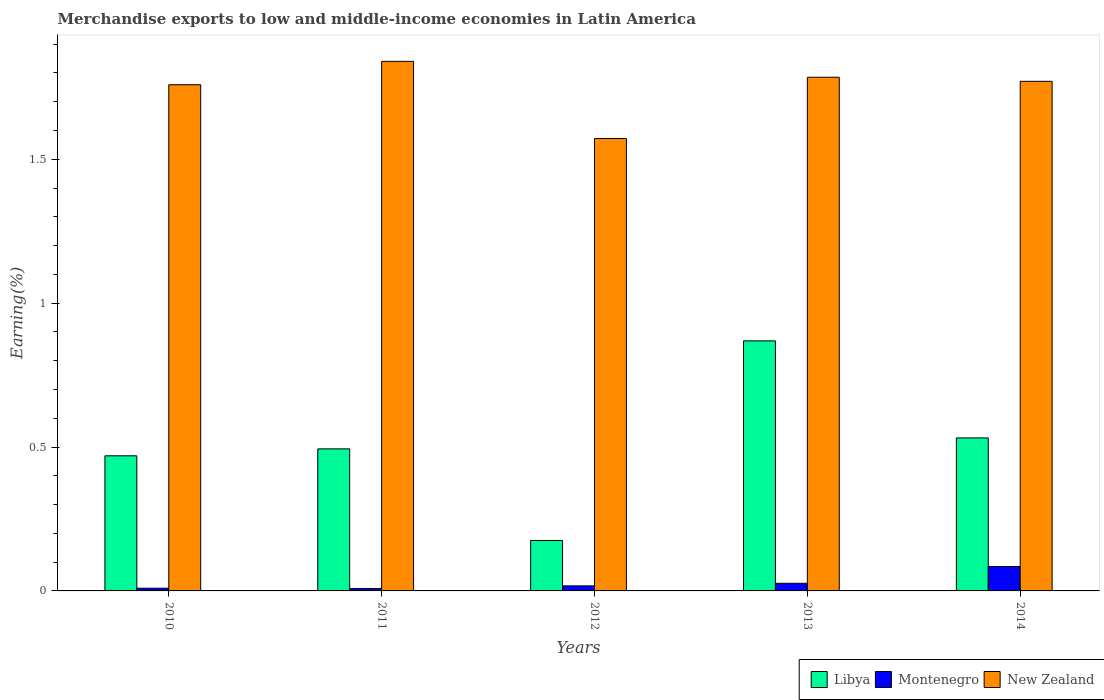How many different coloured bars are there?
Give a very brief answer. 3. How many groups of bars are there?
Keep it short and to the point. 5. Are the number of bars on each tick of the X-axis equal?
Give a very brief answer. Yes. How many bars are there on the 5th tick from the left?
Offer a very short reply. 3. In how many cases, is the number of bars for a given year not equal to the number of legend labels?
Ensure brevity in your answer.  0. What is the percentage of amount earned from merchandise exports in New Zealand in 2012?
Give a very brief answer. 1.57. Across all years, what is the maximum percentage of amount earned from merchandise exports in Montenegro?
Give a very brief answer. 0.08. Across all years, what is the minimum percentage of amount earned from merchandise exports in Libya?
Your answer should be compact. 0.18. In which year was the percentage of amount earned from merchandise exports in Libya maximum?
Offer a terse response. 2013. What is the total percentage of amount earned from merchandise exports in New Zealand in the graph?
Provide a succinct answer. 8.73. What is the difference between the percentage of amount earned from merchandise exports in Montenegro in 2011 and that in 2013?
Make the answer very short. -0.02. What is the difference between the percentage of amount earned from merchandise exports in New Zealand in 2010 and the percentage of amount earned from merchandise exports in Libya in 2012?
Provide a succinct answer. 1.58. What is the average percentage of amount earned from merchandise exports in New Zealand per year?
Your answer should be compact. 1.75. In the year 2010, what is the difference between the percentage of amount earned from merchandise exports in Montenegro and percentage of amount earned from merchandise exports in Libya?
Provide a short and direct response. -0.46. What is the ratio of the percentage of amount earned from merchandise exports in New Zealand in 2013 to that in 2014?
Provide a succinct answer. 1.01. Is the difference between the percentage of amount earned from merchandise exports in Montenegro in 2012 and 2014 greater than the difference between the percentage of amount earned from merchandise exports in Libya in 2012 and 2014?
Give a very brief answer. Yes. What is the difference between the highest and the second highest percentage of amount earned from merchandise exports in Montenegro?
Provide a succinct answer. 0.06. What is the difference between the highest and the lowest percentage of amount earned from merchandise exports in Montenegro?
Keep it short and to the point. 0.08. In how many years, is the percentage of amount earned from merchandise exports in Libya greater than the average percentage of amount earned from merchandise exports in Libya taken over all years?
Provide a succinct answer. 2. What does the 2nd bar from the left in 2010 represents?
Provide a short and direct response. Montenegro. What does the 3rd bar from the right in 2011 represents?
Give a very brief answer. Libya. Is it the case that in every year, the sum of the percentage of amount earned from merchandise exports in Montenegro and percentage of amount earned from merchandise exports in Libya is greater than the percentage of amount earned from merchandise exports in New Zealand?
Offer a terse response. No. How many bars are there?
Your response must be concise. 15. How many years are there in the graph?
Your answer should be compact. 5. Are the values on the major ticks of Y-axis written in scientific E-notation?
Provide a short and direct response. No. Does the graph contain any zero values?
Your answer should be very brief. No. Where does the legend appear in the graph?
Provide a short and direct response. Bottom right. How are the legend labels stacked?
Make the answer very short. Horizontal. What is the title of the graph?
Your answer should be very brief. Merchandise exports to low and middle-income economies in Latin America. Does "Cabo Verde" appear as one of the legend labels in the graph?
Your answer should be very brief. No. What is the label or title of the Y-axis?
Keep it short and to the point. Earning(%). What is the Earning(%) of Libya in 2010?
Ensure brevity in your answer.  0.47. What is the Earning(%) in Montenegro in 2010?
Give a very brief answer. 0.01. What is the Earning(%) of New Zealand in 2010?
Make the answer very short. 1.76. What is the Earning(%) in Libya in 2011?
Provide a succinct answer. 0.49. What is the Earning(%) of Montenegro in 2011?
Keep it short and to the point. 0.01. What is the Earning(%) in New Zealand in 2011?
Provide a short and direct response. 1.84. What is the Earning(%) of Libya in 2012?
Offer a very short reply. 0.18. What is the Earning(%) in Montenegro in 2012?
Your answer should be very brief. 0.02. What is the Earning(%) in New Zealand in 2012?
Give a very brief answer. 1.57. What is the Earning(%) of Libya in 2013?
Your answer should be compact. 0.87. What is the Earning(%) in Montenegro in 2013?
Your answer should be very brief. 0.03. What is the Earning(%) in New Zealand in 2013?
Provide a succinct answer. 1.79. What is the Earning(%) of Libya in 2014?
Provide a succinct answer. 0.53. What is the Earning(%) in Montenegro in 2014?
Keep it short and to the point. 0.08. What is the Earning(%) of New Zealand in 2014?
Your answer should be very brief. 1.77. Across all years, what is the maximum Earning(%) of Libya?
Ensure brevity in your answer.  0.87. Across all years, what is the maximum Earning(%) of Montenegro?
Provide a short and direct response. 0.08. Across all years, what is the maximum Earning(%) in New Zealand?
Your answer should be very brief. 1.84. Across all years, what is the minimum Earning(%) in Libya?
Keep it short and to the point. 0.18. Across all years, what is the minimum Earning(%) in Montenegro?
Keep it short and to the point. 0.01. Across all years, what is the minimum Earning(%) in New Zealand?
Ensure brevity in your answer.  1.57. What is the total Earning(%) in Libya in the graph?
Make the answer very short. 2.54. What is the total Earning(%) in Montenegro in the graph?
Offer a very short reply. 0.15. What is the total Earning(%) in New Zealand in the graph?
Your response must be concise. 8.73. What is the difference between the Earning(%) of Libya in 2010 and that in 2011?
Make the answer very short. -0.02. What is the difference between the Earning(%) of Montenegro in 2010 and that in 2011?
Offer a very short reply. 0. What is the difference between the Earning(%) of New Zealand in 2010 and that in 2011?
Your answer should be very brief. -0.08. What is the difference between the Earning(%) of Libya in 2010 and that in 2012?
Give a very brief answer. 0.29. What is the difference between the Earning(%) in Montenegro in 2010 and that in 2012?
Provide a succinct answer. -0.01. What is the difference between the Earning(%) of New Zealand in 2010 and that in 2012?
Give a very brief answer. 0.19. What is the difference between the Earning(%) in Libya in 2010 and that in 2013?
Provide a succinct answer. -0.4. What is the difference between the Earning(%) of Montenegro in 2010 and that in 2013?
Offer a very short reply. -0.02. What is the difference between the Earning(%) of New Zealand in 2010 and that in 2013?
Offer a very short reply. -0.03. What is the difference between the Earning(%) of Libya in 2010 and that in 2014?
Make the answer very short. -0.06. What is the difference between the Earning(%) in Montenegro in 2010 and that in 2014?
Ensure brevity in your answer.  -0.08. What is the difference between the Earning(%) in New Zealand in 2010 and that in 2014?
Your answer should be compact. -0.01. What is the difference between the Earning(%) of Libya in 2011 and that in 2012?
Give a very brief answer. 0.32. What is the difference between the Earning(%) of Montenegro in 2011 and that in 2012?
Make the answer very short. -0.01. What is the difference between the Earning(%) in New Zealand in 2011 and that in 2012?
Make the answer very short. 0.27. What is the difference between the Earning(%) in Libya in 2011 and that in 2013?
Provide a succinct answer. -0.38. What is the difference between the Earning(%) of Montenegro in 2011 and that in 2013?
Ensure brevity in your answer.  -0.02. What is the difference between the Earning(%) of New Zealand in 2011 and that in 2013?
Ensure brevity in your answer.  0.06. What is the difference between the Earning(%) in Libya in 2011 and that in 2014?
Provide a succinct answer. -0.04. What is the difference between the Earning(%) in Montenegro in 2011 and that in 2014?
Offer a terse response. -0.08. What is the difference between the Earning(%) in New Zealand in 2011 and that in 2014?
Ensure brevity in your answer.  0.07. What is the difference between the Earning(%) of Libya in 2012 and that in 2013?
Offer a very short reply. -0.69. What is the difference between the Earning(%) in Montenegro in 2012 and that in 2013?
Your answer should be very brief. -0.01. What is the difference between the Earning(%) in New Zealand in 2012 and that in 2013?
Offer a very short reply. -0.21. What is the difference between the Earning(%) in Libya in 2012 and that in 2014?
Provide a succinct answer. -0.36. What is the difference between the Earning(%) of Montenegro in 2012 and that in 2014?
Provide a succinct answer. -0.07. What is the difference between the Earning(%) of New Zealand in 2012 and that in 2014?
Offer a terse response. -0.2. What is the difference between the Earning(%) in Libya in 2013 and that in 2014?
Provide a succinct answer. 0.34. What is the difference between the Earning(%) of Montenegro in 2013 and that in 2014?
Provide a short and direct response. -0.06. What is the difference between the Earning(%) of New Zealand in 2013 and that in 2014?
Your answer should be compact. 0.01. What is the difference between the Earning(%) of Libya in 2010 and the Earning(%) of Montenegro in 2011?
Provide a short and direct response. 0.46. What is the difference between the Earning(%) of Libya in 2010 and the Earning(%) of New Zealand in 2011?
Your response must be concise. -1.37. What is the difference between the Earning(%) in Montenegro in 2010 and the Earning(%) in New Zealand in 2011?
Keep it short and to the point. -1.83. What is the difference between the Earning(%) of Libya in 2010 and the Earning(%) of Montenegro in 2012?
Ensure brevity in your answer.  0.45. What is the difference between the Earning(%) of Libya in 2010 and the Earning(%) of New Zealand in 2012?
Make the answer very short. -1.1. What is the difference between the Earning(%) of Montenegro in 2010 and the Earning(%) of New Zealand in 2012?
Keep it short and to the point. -1.56. What is the difference between the Earning(%) of Libya in 2010 and the Earning(%) of Montenegro in 2013?
Give a very brief answer. 0.44. What is the difference between the Earning(%) in Libya in 2010 and the Earning(%) in New Zealand in 2013?
Ensure brevity in your answer.  -1.32. What is the difference between the Earning(%) in Montenegro in 2010 and the Earning(%) in New Zealand in 2013?
Your answer should be compact. -1.78. What is the difference between the Earning(%) of Libya in 2010 and the Earning(%) of Montenegro in 2014?
Provide a succinct answer. 0.38. What is the difference between the Earning(%) in Libya in 2010 and the Earning(%) in New Zealand in 2014?
Provide a short and direct response. -1.3. What is the difference between the Earning(%) of Montenegro in 2010 and the Earning(%) of New Zealand in 2014?
Your answer should be very brief. -1.76. What is the difference between the Earning(%) in Libya in 2011 and the Earning(%) in Montenegro in 2012?
Provide a short and direct response. 0.48. What is the difference between the Earning(%) in Libya in 2011 and the Earning(%) in New Zealand in 2012?
Your answer should be compact. -1.08. What is the difference between the Earning(%) in Montenegro in 2011 and the Earning(%) in New Zealand in 2012?
Make the answer very short. -1.56. What is the difference between the Earning(%) in Libya in 2011 and the Earning(%) in Montenegro in 2013?
Provide a short and direct response. 0.47. What is the difference between the Earning(%) in Libya in 2011 and the Earning(%) in New Zealand in 2013?
Keep it short and to the point. -1.29. What is the difference between the Earning(%) of Montenegro in 2011 and the Earning(%) of New Zealand in 2013?
Your answer should be very brief. -1.78. What is the difference between the Earning(%) in Libya in 2011 and the Earning(%) in Montenegro in 2014?
Offer a terse response. 0.41. What is the difference between the Earning(%) in Libya in 2011 and the Earning(%) in New Zealand in 2014?
Offer a terse response. -1.28. What is the difference between the Earning(%) of Montenegro in 2011 and the Earning(%) of New Zealand in 2014?
Give a very brief answer. -1.76. What is the difference between the Earning(%) in Libya in 2012 and the Earning(%) in Montenegro in 2013?
Your answer should be compact. 0.15. What is the difference between the Earning(%) of Libya in 2012 and the Earning(%) of New Zealand in 2013?
Make the answer very short. -1.61. What is the difference between the Earning(%) in Montenegro in 2012 and the Earning(%) in New Zealand in 2013?
Your answer should be very brief. -1.77. What is the difference between the Earning(%) in Libya in 2012 and the Earning(%) in Montenegro in 2014?
Offer a terse response. 0.09. What is the difference between the Earning(%) of Libya in 2012 and the Earning(%) of New Zealand in 2014?
Offer a terse response. -1.6. What is the difference between the Earning(%) in Montenegro in 2012 and the Earning(%) in New Zealand in 2014?
Keep it short and to the point. -1.75. What is the difference between the Earning(%) in Libya in 2013 and the Earning(%) in Montenegro in 2014?
Give a very brief answer. 0.78. What is the difference between the Earning(%) of Libya in 2013 and the Earning(%) of New Zealand in 2014?
Offer a terse response. -0.9. What is the difference between the Earning(%) in Montenegro in 2013 and the Earning(%) in New Zealand in 2014?
Give a very brief answer. -1.74. What is the average Earning(%) of Libya per year?
Give a very brief answer. 0.51. What is the average Earning(%) of Montenegro per year?
Provide a succinct answer. 0.03. What is the average Earning(%) in New Zealand per year?
Ensure brevity in your answer.  1.75. In the year 2010, what is the difference between the Earning(%) in Libya and Earning(%) in Montenegro?
Your answer should be compact. 0.46. In the year 2010, what is the difference between the Earning(%) of Libya and Earning(%) of New Zealand?
Your response must be concise. -1.29. In the year 2010, what is the difference between the Earning(%) in Montenegro and Earning(%) in New Zealand?
Offer a very short reply. -1.75. In the year 2011, what is the difference between the Earning(%) of Libya and Earning(%) of Montenegro?
Give a very brief answer. 0.49. In the year 2011, what is the difference between the Earning(%) of Libya and Earning(%) of New Zealand?
Give a very brief answer. -1.35. In the year 2011, what is the difference between the Earning(%) of Montenegro and Earning(%) of New Zealand?
Offer a terse response. -1.83. In the year 2012, what is the difference between the Earning(%) of Libya and Earning(%) of Montenegro?
Your answer should be very brief. 0.16. In the year 2012, what is the difference between the Earning(%) of Libya and Earning(%) of New Zealand?
Provide a succinct answer. -1.4. In the year 2012, what is the difference between the Earning(%) in Montenegro and Earning(%) in New Zealand?
Your answer should be compact. -1.55. In the year 2013, what is the difference between the Earning(%) of Libya and Earning(%) of Montenegro?
Ensure brevity in your answer.  0.84. In the year 2013, what is the difference between the Earning(%) in Libya and Earning(%) in New Zealand?
Ensure brevity in your answer.  -0.92. In the year 2013, what is the difference between the Earning(%) of Montenegro and Earning(%) of New Zealand?
Ensure brevity in your answer.  -1.76. In the year 2014, what is the difference between the Earning(%) in Libya and Earning(%) in Montenegro?
Your answer should be very brief. 0.45. In the year 2014, what is the difference between the Earning(%) of Libya and Earning(%) of New Zealand?
Keep it short and to the point. -1.24. In the year 2014, what is the difference between the Earning(%) in Montenegro and Earning(%) in New Zealand?
Offer a terse response. -1.69. What is the ratio of the Earning(%) in Libya in 2010 to that in 2011?
Ensure brevity in your answer.  0.95. What is the ratio of the Earning(%) of Montenegro in 2010 to that in 2011?
Offer a very short reply. 1.15. What is the ratio of the Earning(%) of New Zealand in 2010 to that in 2011?
Make the answer very short. 0.96. What is the ratio of the Earning(%) of Libya in 2010 to that in 2012?
Ensure brevity in your answer.  2.68. What is the ratio of the Earning(%) of Montenegro in 2010 to that in 2012?
Offer a terse response. 0.54. What is the ratio of the Earning(%) of New Zealand in 2010 to that in 2012?
Offer a terse response. 1.12. What is the ratio of the Earning(%) in Libya in 2010 to that in 2013?
Provide a short and direct response. 0.54. What is the ratio of the Earning(%) of Montenegro in 2010 to that in 2013?
Offer a very short reply. 0.36. What is the ratio of the Earning(%) in New Zealand in 2010 to that in 2013?
Your answer should be very brief. 0.99. What is the ratio of the Earning(%) in Libya in 2010 to that in 2014?
Your answer should be compact. 0.88. What is the ratio of the Earning(%) of Montenegro in 2010 to that in 2014?
Keep it short and to the point. 0.11. What is the ratio of the Earning(%) in New Zealand in 2010 to that in 2014?
Your response must be concise. 0.99. What is the ratio of the Earning(%) of Libya in 2011 to that in 2012?
Provide a succinct answer. 2.82. What is the ratio of the Earning(%) of Montenegro in 2011 to that in 2012?
Provide a short and direct response. 0.47. What is the ratio of the Earning(%) in New Zealand in 2011 to that in 2012?
Make the answer very short. 1.17. What is the ratio of the Earning(%) of Libya in 2011 to that in 2013?
Your answer should be compact. 0.57. What is the ratio of the Earning(%) of Montenegro in 2011 to that in 2013?
Provide a short and direct response. 0.31. What is the ratio of the Earning(%) in New Zealand in 2011 to that in 2013?
Provide a short and direct response. 1.03. What is the ratio of the Earning(%) of Libya in 2011 to that in 2014?
Your answer should be very brief. 0.93. What is the ratio of the Earning(%) in Montenegro in 2011 to that in 2014?
Make the answer very short. 0.1. What is the ratio of the Earning(%) in New Zealand in 2011 to that in 2014?
Offer a terse response. 1.04. What is the ratio of the Earning(%) in Libya in 2012 to that in 2013?
Provide a short and direct response. 0.2. What is the ratio of the Earning(%) in Montenegro in 2012 to that in 2013?
Give a very brief answer. 0.66. What is the ratio of the Earning(%) in New Zealand in 2012 to that in 2013?
Your answer should be very brief. 0.88. What is the ratio of the Earning(%) of Libya in 2012 to that in 2014?
Keep it short and to the point. 0.33. What is the ratio of the Earning(%) in Montenegro in 2012 to that in 2014?
Your answer should be compact. 0.21. What is the ratio of the Earning(%) of New Zealand in 2012 to that in 2014?
Your response must be concise. 0.89. What is the ratio of the Earning(%) of Libya in 2013 to that in 2014?
Ensure brevity in your answer.  1.63. What is the ratio of the Earning(%) of Montenegro in 2013 to that in 2014?
Your answer should be very brief. 0.31. What is the ratio of the Earning(%) in New Zealand in 2013 to that in 2014?
Keep it short and to the point. 1.01. What is the difference between the highest and the second highest Earning(%) in Libya?
Ensure brevity in your answer.  0.34. What is the difference between the highest and the second highest Earning(%) in Montenegro?
Give a very brief answer. 0.06. What is the difference between the highest and the second highest Earning(%) in New Zealand?
Keep it short and to the point. 0.06. What is the difference between the highest and the lowest Earning(%) of Libya?
Ensure brevity in your answer.  0.69. What is the difference between the highest and the lowest Earning(%) of Montenegro?
Give a very brief answer. 0.08. What is the difference between the highest and the lowest Earning(%) in New Zealand?
Keep it short and to the point. 0.27. 